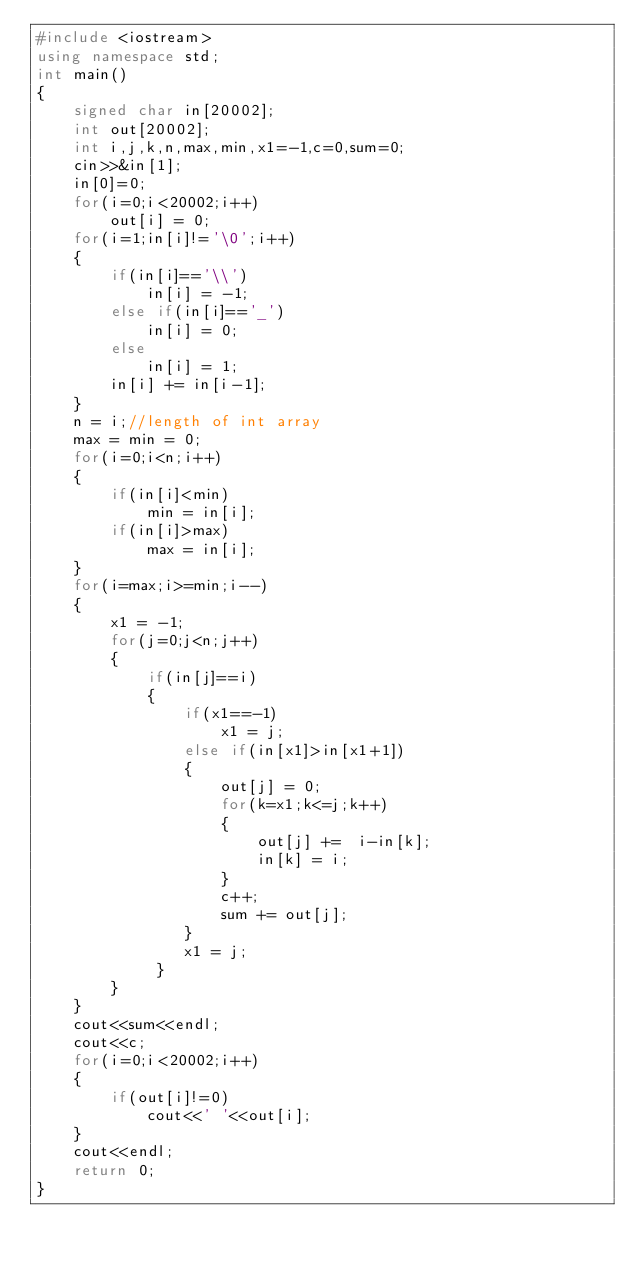Convert code to text. <code><loc_0><loc_0><loc_500><loc_500><_C++_>#include <iostream>
using namespace std;
int main()
{
    signed char in[20002];
    int out[20002];
    int i,j,k,n,max,min,x1=-1,c=0,sum=0;
    cin>>&in[1];
    in[0]=0;
    for(i=0;i<20002;i++)
        out[i] = 0;
    for(i=1;in[i]!='\0';i++)
    {
        if(in[i]=='\\')
            in[i] = -1;
        else if(in[i]=='_')
            in[i] = 0;
        else
            in[i] = 1;
        in[i] += in[i-1];
    }
    n = i;//length of int array
    max = min = 0;
    for(i=0;i<n;i++)
    {
        if(in[i]<min)
            min = in[i];
        if(in[i]>max)
            max = in[i];
    }
    for(i=max;i>=min;i--)
    {
        x1 = -1;
        for(j=0;j<n;j++)
        {
            if(in[j]==i)
            {
                if(x1==-1)
                    x1 = j;
                else if(in[x1]>in[x1+1])
                {
                    out[j] = 0;
                    for(k=x1;k<=j;k++)
                    {
                        out[j] +=  i-in[k];
                        in[k] = i;
                    }
                    c++;
                    sum += out[j];
                }
                x1 = j;
             }
        }
    }
    cout<<sum<<endl;
    cout<<c;
    for(i=0;i<20002;i++)
    {
        if(out[i]!=0)
            cout<<' '<<out[i];
    }
    cout<<endl;
    return 0;
}</code> 